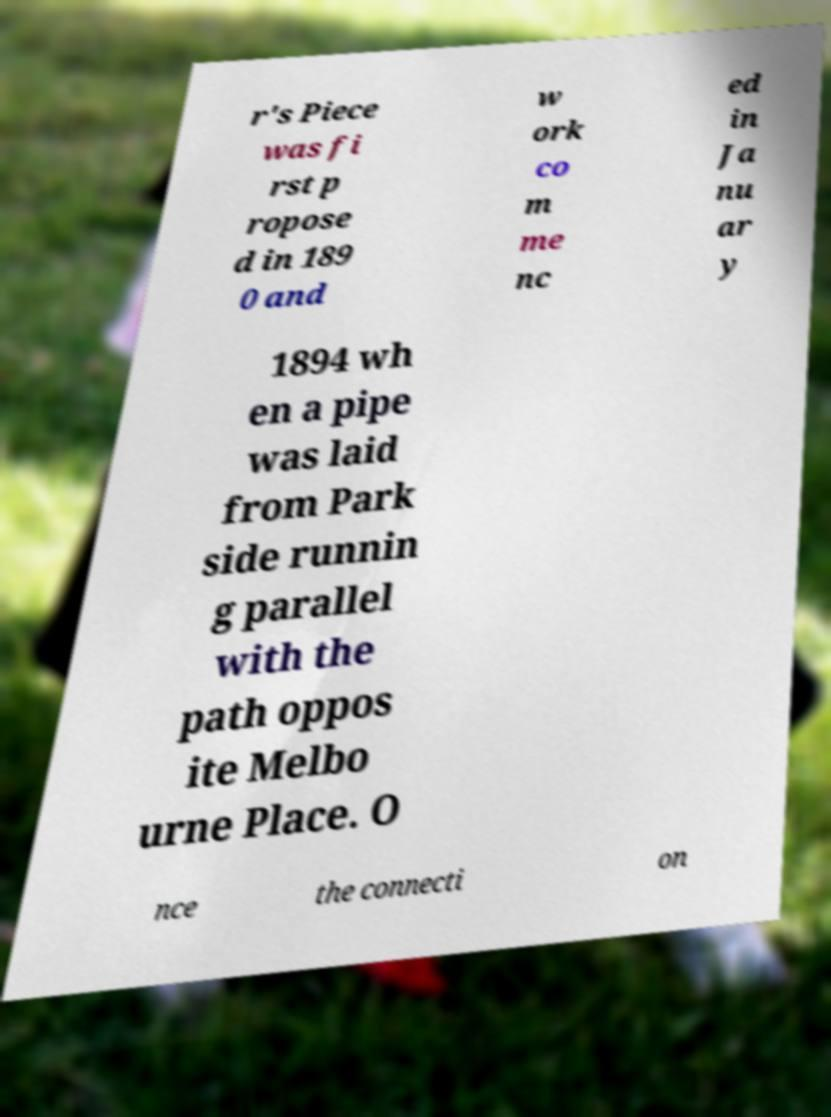Please read and relay the text visible in this image. What does it say? r's Piece was fi rst p ropose d in 189 0 and w ork co m me nc ed in Ja nu ar y 1894 wh en a pipe was laid from Park side runnin g parallel with the path oppos ite Melbo urne Place. O nce the connecti on 